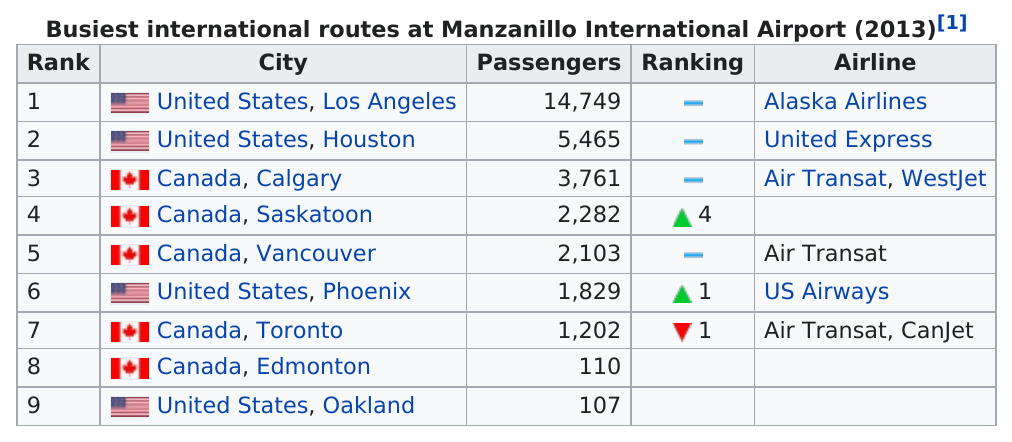Outline some significant characteristics in this image. Alaska Airlines carries the greatest number of passengers among all airlines. Four airlines consistently rank among the top performers. According to data from Manzanillo International Airport in 2013, Calgary, a city in Canada, had the highest number of passengers traveling from the airport. According to the information provided, there were 1,829 passengers in Phoenix, Arizona. On January 31st, 5,465 passengers flew after Los Angeles, a city located in the United States, had flown. 